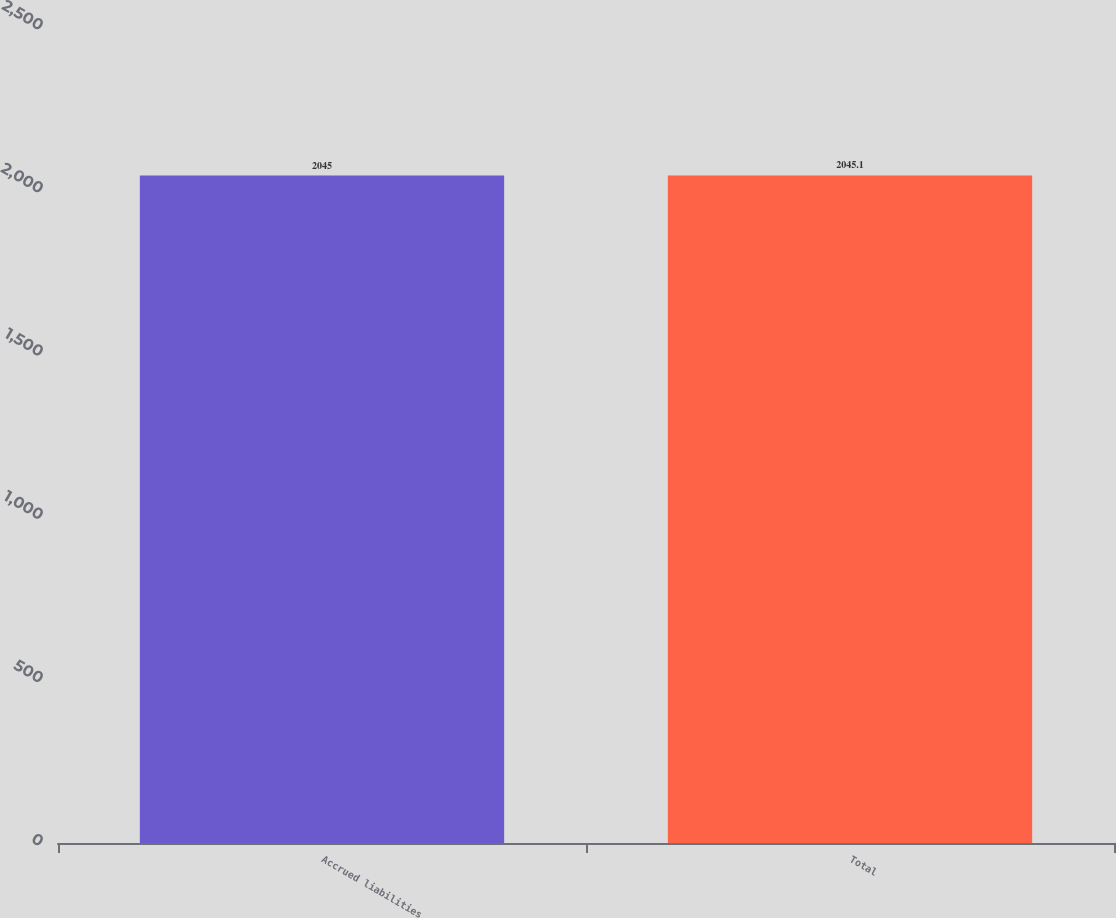Convert chart. <chart><loc_0><loc_0><loc_500><loc_500><bar_chart><fcel>Accrued liabilities<fcel>Total<nl><fcel>2045<fcel>2045.1<nl></chart> 